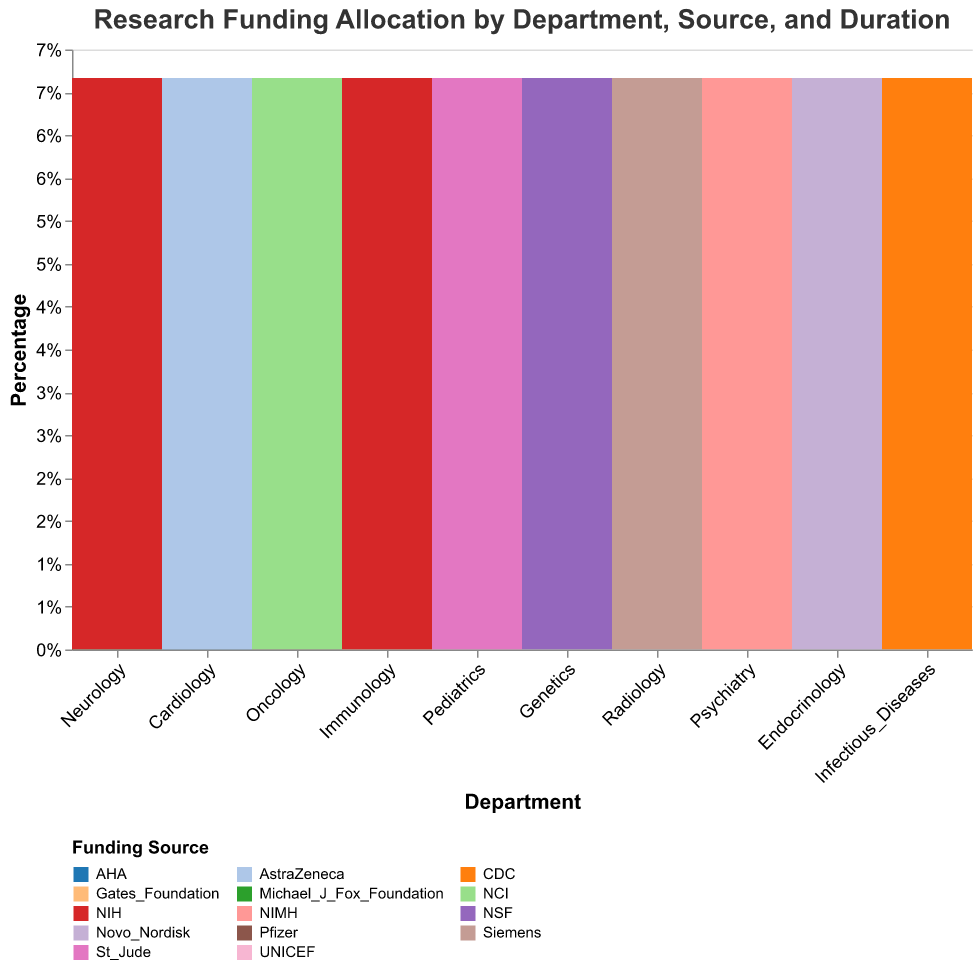What is the primary funding source for the Oncology department? To identify the primary funding source, locate the Oncology department on the x-axis and observe the segments within the column. The largest segment will indicate the primary funding source.
Answer: NCI Which department receives the highest percentage of NIH funding? To determine this, find the segments corresponding to NIH funding across all departments. Compare the heights of these individual segments. The tallest segment will show the department with the highest percentage.
Answer: Neurology How many departments have received funding for projects lasting 3 years? Observe the legend for project duration and identify which segments are labeled as "3 Years". Count the number of departments that have these segments within their columns.
Answer: Five Which funding source has the most diverse allocation across different departments? To find the most diverse allocation, examine the variety and number of departments represented by each funding source in the color legend. The funding source with segments in the most distinct departments is the answer.
Answer: NIH Compare the funding allocations for the Neurology and Cardiology departments: which one has a more diverse range of funding sources? Locate the Neurology and Cardiology columns and count the different colored segments in each. The column with more different colors indicates a more diverse range of funding sources.
Answer: Cardiology Does the Pediatrics department have any sources of funding for projects longer than 3 years? Look at the Pediatrics column and check the colors and labels associated with durations longer than 3 years.
Answer: No What is the total number of departments receiving funding from private foundations (Michael J Fox Foundation, Gates Foundation, etc.)? Identify the segments in colors representing private foundations and count the distinct departments containing these segments.
Answer: Six Which department has the largest segment for funding received from a pharmaceutical company (e.g., Siemens, AstraZeneca, Pfizer)? Focus on the segments colored for pharmaceutical companies and compare their sizes across departments. Identify the largest of these segments.
Answer: Oncology (Pfizer) In which department does the Gates Foundation contribute the highest proportion of funding? Locate the segments representing the Gates Foundation. Check their relative sizes within each respective department to find the largest segment.
Answer: Immunology 